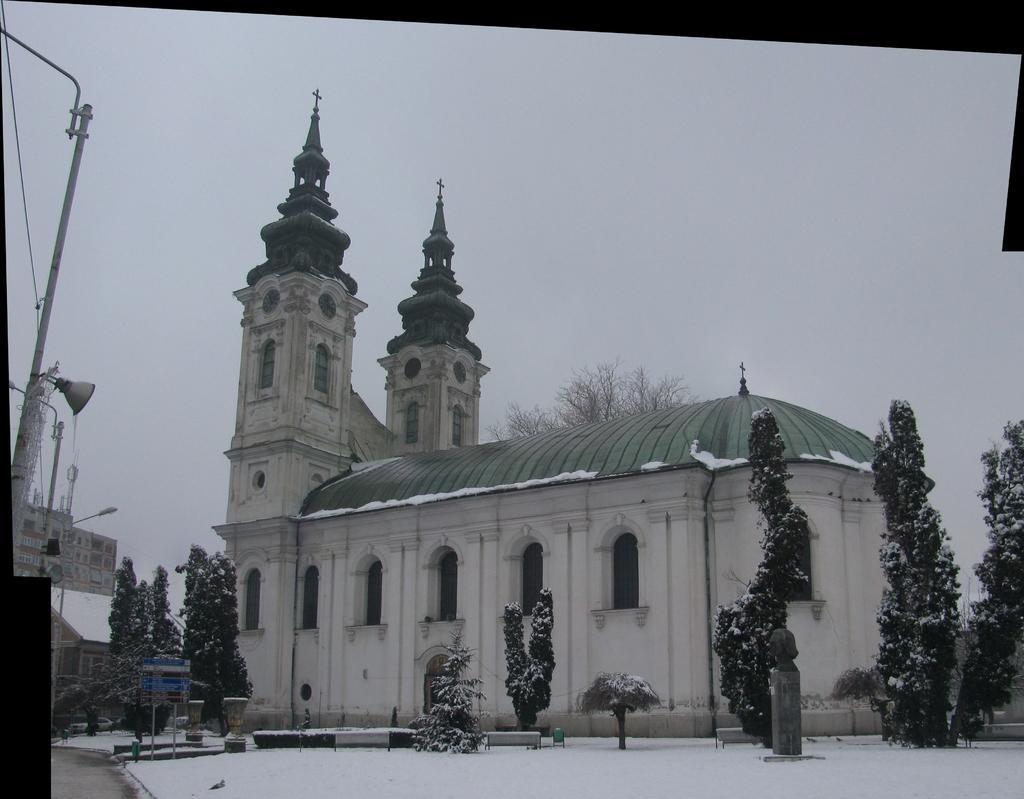In one or two sentences, can you explain what this image depicts? In this image we can see there are buildings and trees with snow. And there is a board, speaker, street light, pole and the sky. 